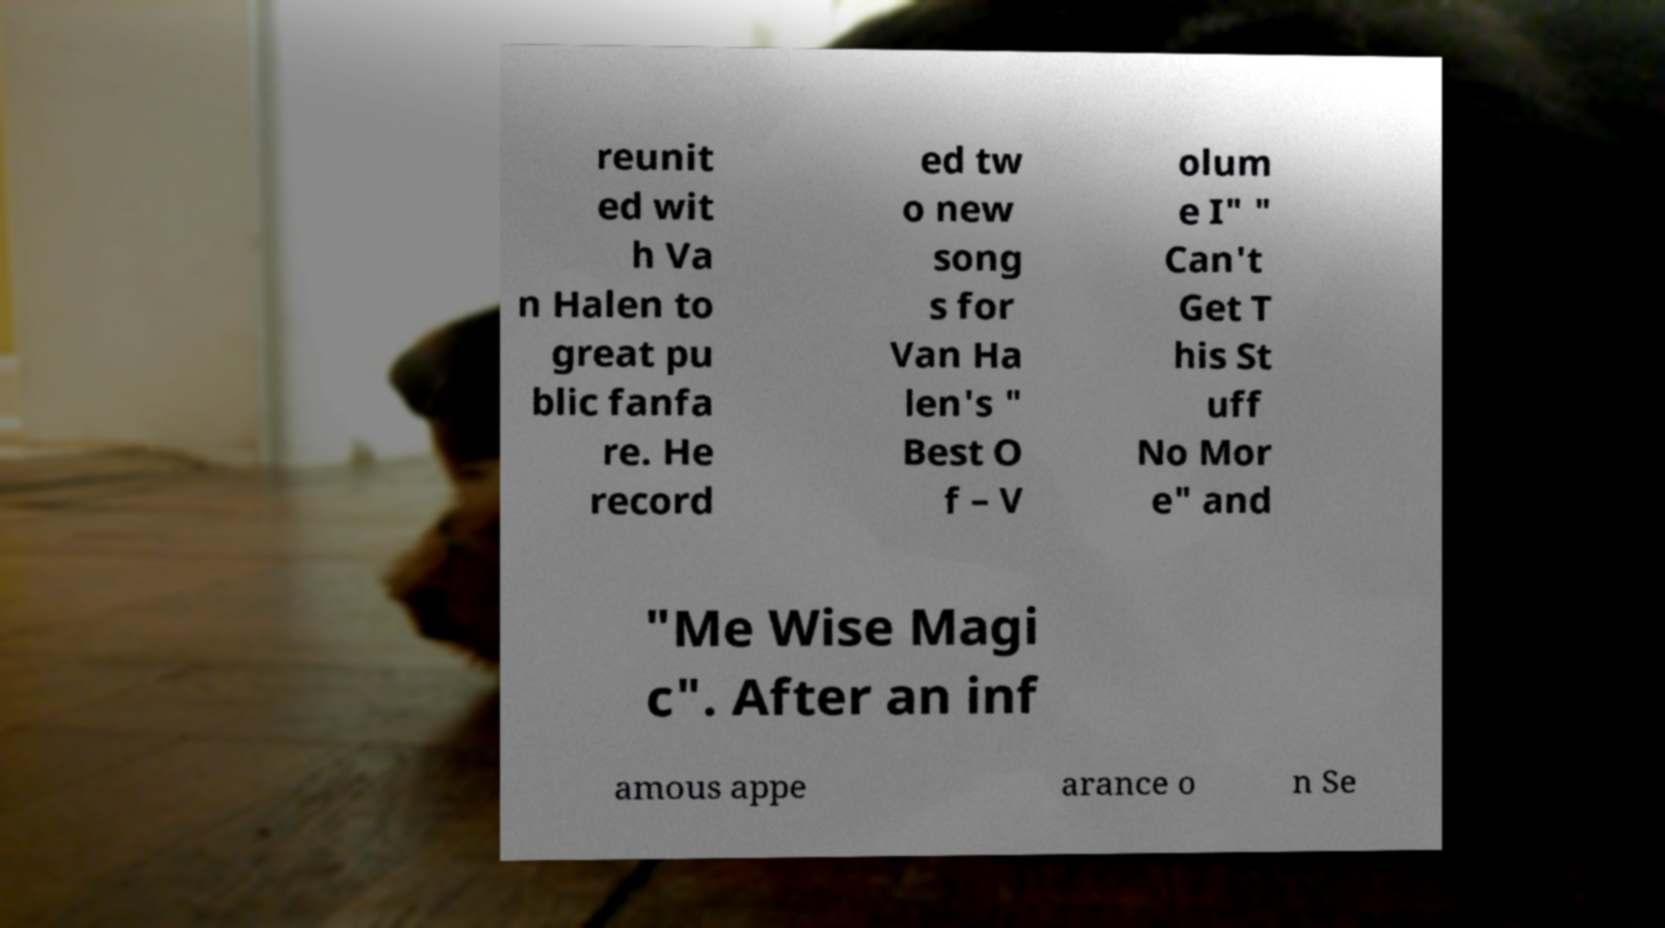For documentation purposes, I need the text within this image transcribed. Could you provide that? reunit ed wit h Va n Halen to great pu blic fanfa re. He record ed tw o new song s for Van Ha len's " Best O f – V olum e I" " Can't Get T his St uff No Mor e" and "Me Wise Magi c". After an inf amous appe arance o n Se 